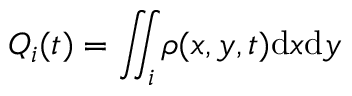<formula> <loc_0><loc_0><loc_500><loc_500>Q _ { i } ( t ) = \iint _ { i } \rho ( x , y , t ) d x d y</formula> 